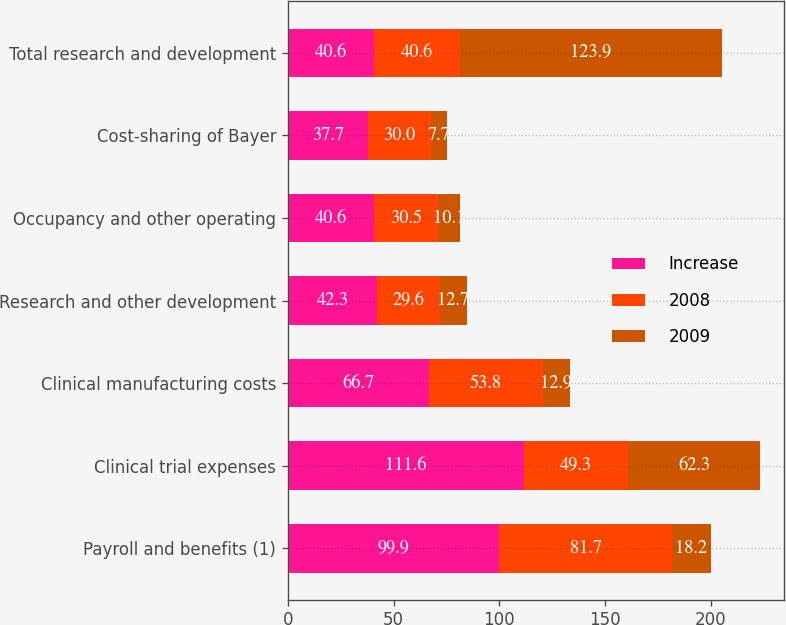<chart> <loc_0><loc_0><loc_500><loc_500><stacked_bar_chart><ecel><fcel>Payroll and benefits (1)<fcel>Clinical trial expenses<fcel>Clinical manufacturing costs<fcel>Research and other development<fcel>Occupancy and other operating<fcel>Cost-sharing of Bayer<fcel>Total research and development<nl><fcel>Increase<fcel>99.9<fcel>111.6<fcel>66.7<fcel>42.3<fcel>40.6<fcel>37.7<fcel>40.6<nl><fcel>2008<fcel>81.7<fcel>49.3<fcel>53.8<fcel>29.6<fcel>30.5<fcel>30<fcel>40.6<nl><fcel>2009<fcel>18.2<fcel>62.3<fcel>12.9<fcel>12.7<fcel>10.1<fcel>7.7<fcel>123.9<nl></chart> 